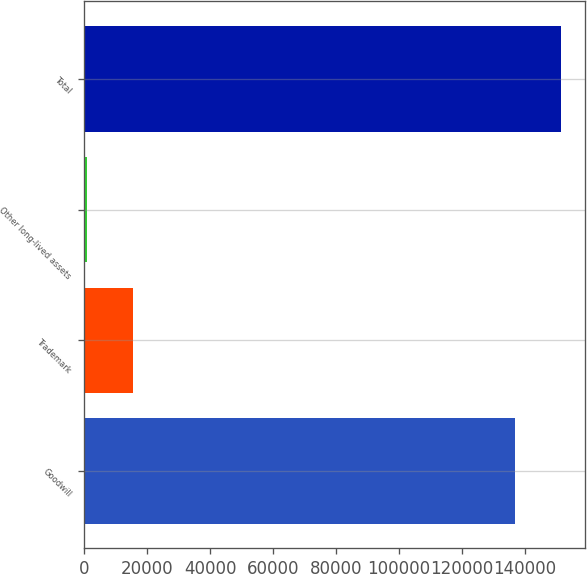<chart> <loc_0><loc_0><loc_500><loc_500><bar_chart><fcel>Goodwill<fcel>Trademark<fcel>Other long-lived assets<fcel>Total<nl><fcel>136800<fcel>15544<fcel>864<fcel>151480<nl></chart> 